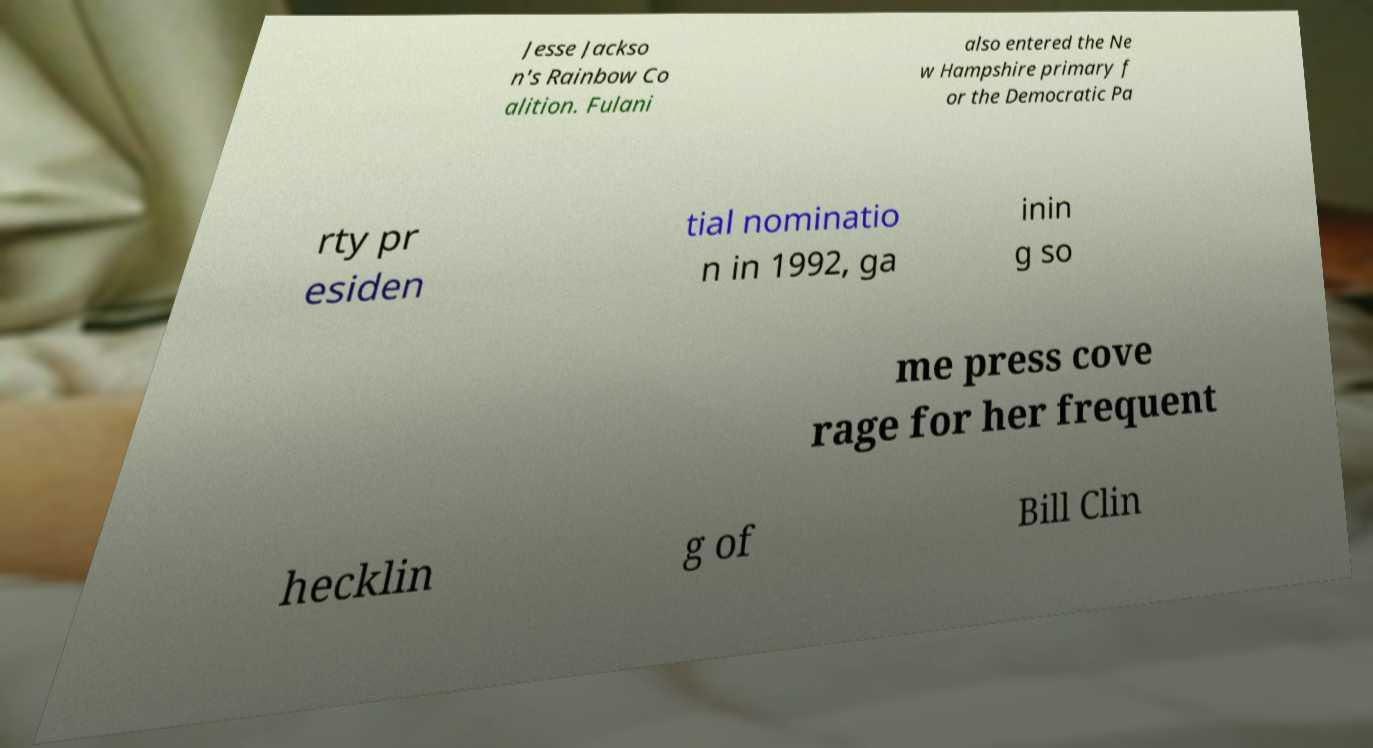Can you accurately transcribe the text from the provided image for me? Jesse Jackso n's Rainbow Co alition. Fulani also entered the Ne w Hampshire primary f or the Democratic Pa rty pr esiden tial nominatio n in 1992, ga inin g so me press cove rage for her frequent hecklin g of Bill Clin 